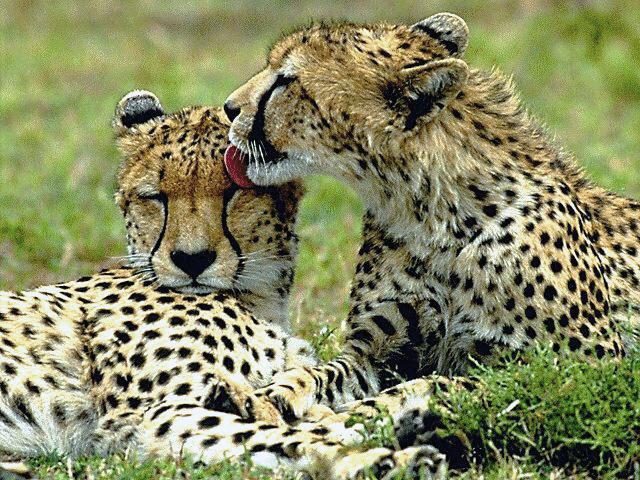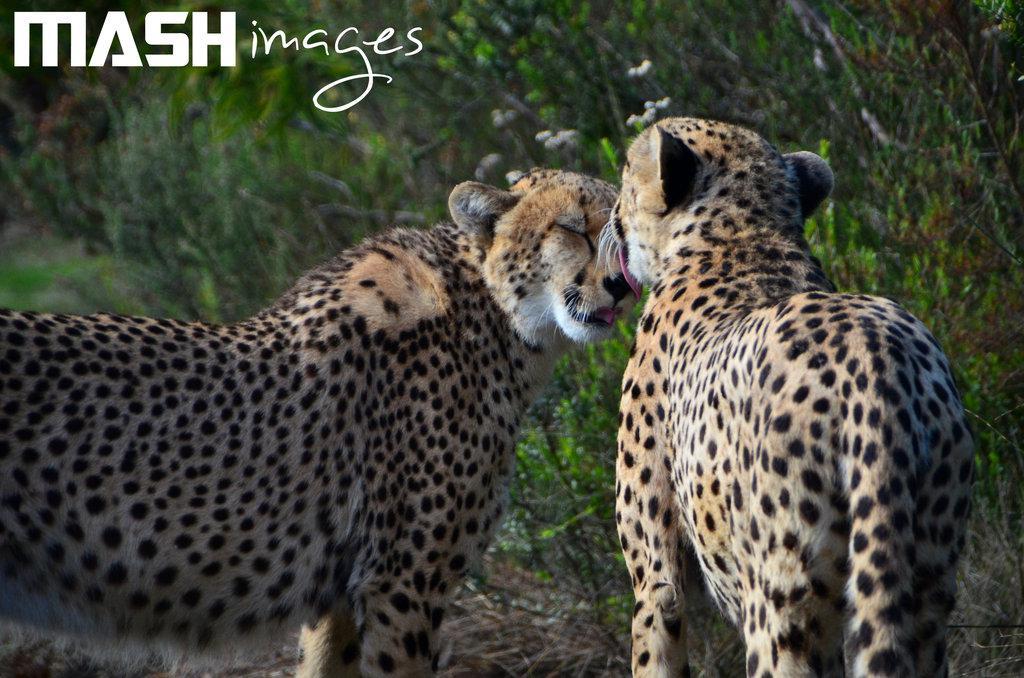The first image is the image on the left, the second image is the image on the right. Given the left and right images, does the statement "One image has two Cheetahs with one licking the other." hold true? Answer yes or no. Yes. 